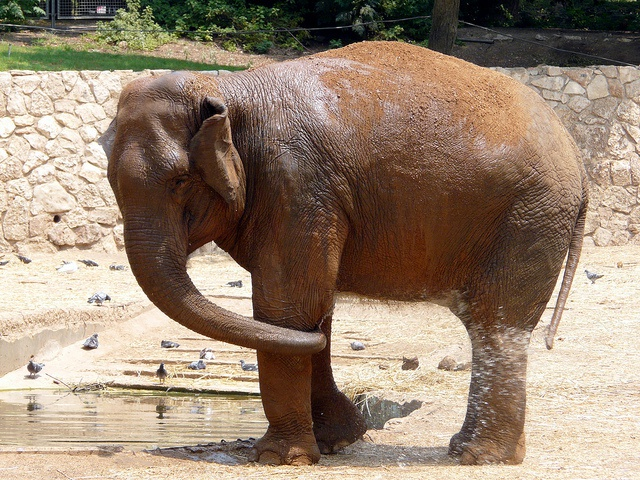Describe the objects in this image and their specific colors. I can see elephant in darkgreen, maroon, black, and gray tones, bird in darkgreen, lightgray, darkgray, gray, and maroon tones, bird in darkgreen, white, darkgray, and gray tones, bird in darkgreen, gray, darkgray, lightgray, and maroon tones, and bird in darkgreen, black, gray, and darkgray tones in this image. 